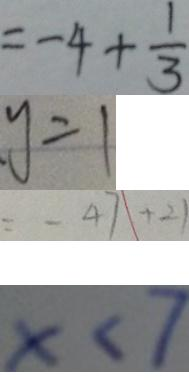Convert formula to latex. <formula><loc_0><loc_0><loc_500><loc_500>= - 4 + \frac { 1 } { 3 } 
 y = 1 
 = - 4 7 + 2 1 
 x < 7</formula> 